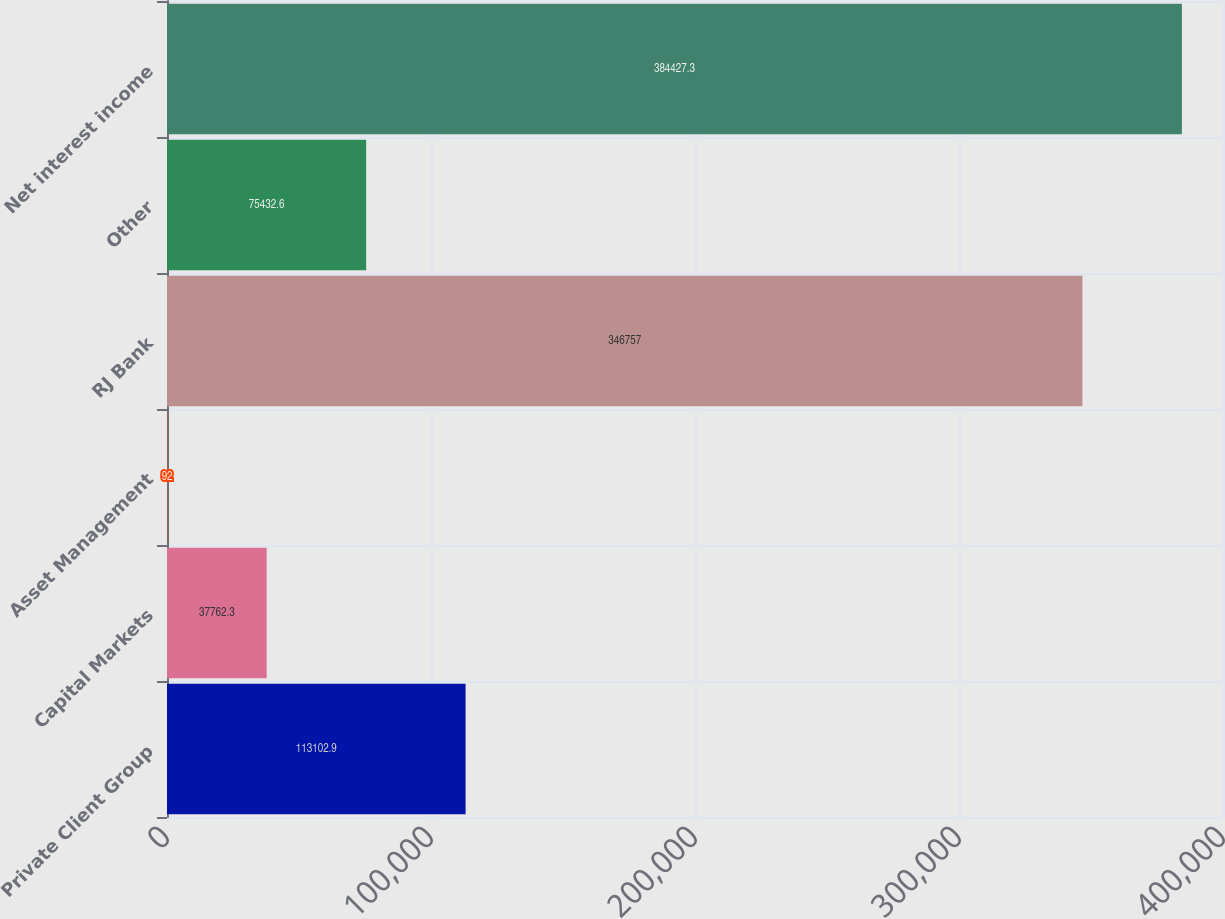Convert chart to OTSL. <chart><loc_0><loc_0><loc_500><loc_500><bar_chart><fcel>Private Client Group<fcel>Capital Markets<fcel>Asset Management<fcel>RJ Bank<fcel>Other<fcel>Net interest income<nl><fcel>113103<fcel>37762.3<fcel>92<fcel>346757<fcel>75432.6<fcel>384427<nl></chart> 